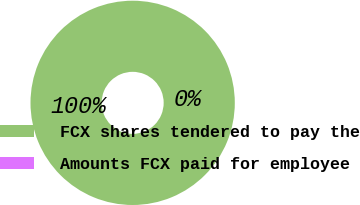Convert chart. <chart><loc_0><loc_0><loc_500><loc_500><pie_chart><fcel>FCX shares tendered to pay the<fcel>Amounts FCX paid for employee<nl><fcel>100.0%<fcel>0.0%<nl></chart> 